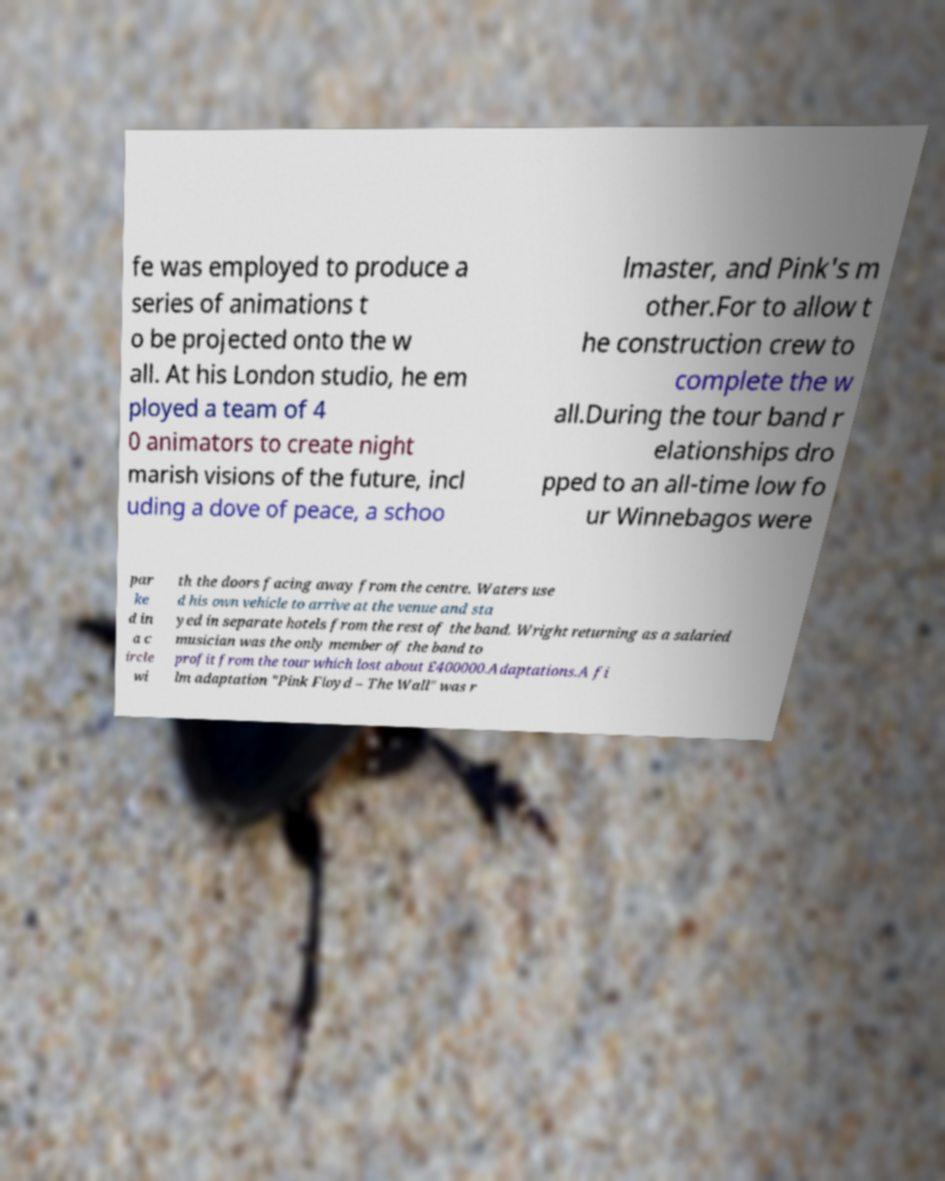Please read and relay the text visible in this image. What does it say? fe was employed to produce a series of animations t o be projected onto the w all. At his London studio, he em ployed a team of 4 0 animators to create night marish visions of the future, incl uding a dove of peace, a schoo lmaster, and Pink's m other.For to allow t he construction crew to complete the w all.During the tour band r elationships dro pped to an all-time low fo ur Winnebagos were par ke d in a c ircle wi th the doors facing away from the centre. Waters use d his own vehicle to arrive at the venue and sta yed in separate hotels from the rest of the band. Wright returning as a salaried musician was the only member of the band to profit from the tour which lost about £400000.Adaptations.A fi lm adaptation "Pink Floyd – The Wall" was r 